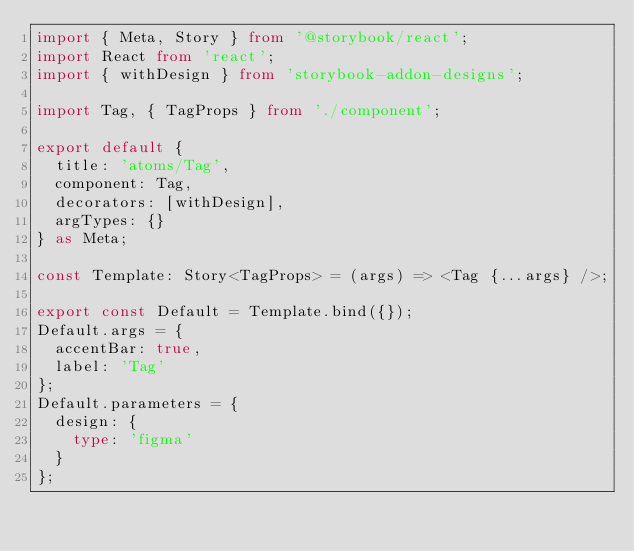<code> <loc_0><loc_0><loc_500><loc_500><_TypeScript_>import { Meta, Story } from '@storybook/react';
import React from 'react';
import { withDesign } from 'storybook-addon-designs';

import Tag, { TagProps } from './component';

export default {
  title: 'atoms/Tag',
  component: Tag,
  decorators: [withDesign],
  argTypes: {}
} as Meta;

const Template: Story<TagProps> = (args) => <Tag {...args} />;

export const Default = Template.bind({});
Default.args = {
  accentBar: true,
  label: 'Tag'
};
Default.parameters = {
  design: {
    type: 'figma'
  }
};
</code> 